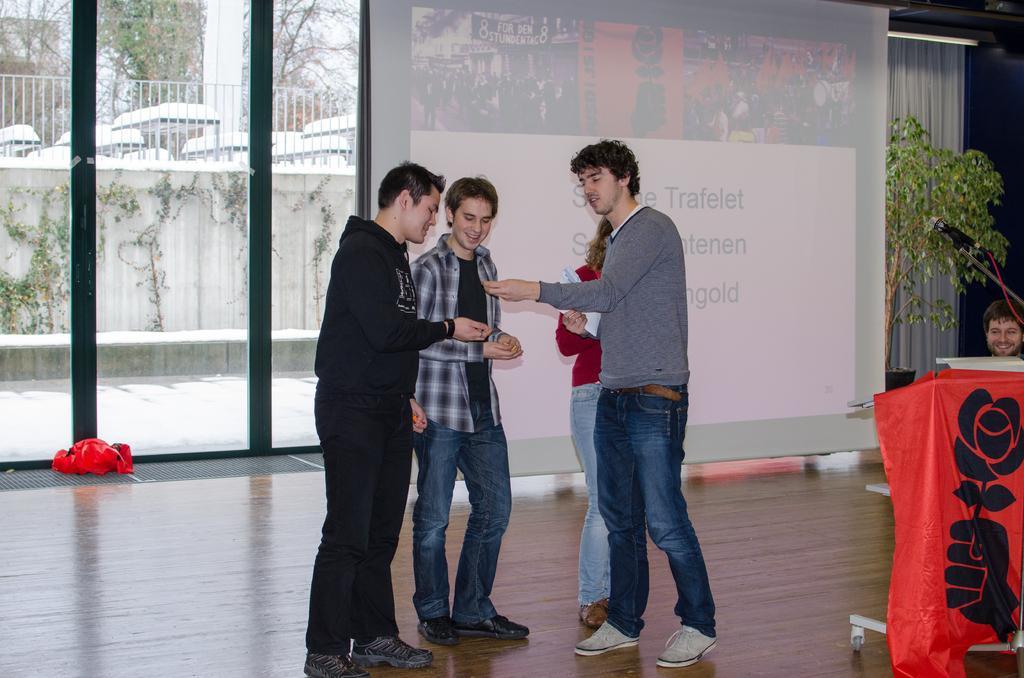Please provide a concise description of this image. In this picture there are people standing. On the right side of the image we can see a person, cloth and leaves. In the background of the image we can see glass, screen, curtain and light, through this glass we can see leaves, wall, fence, trees, sky and white objects. 